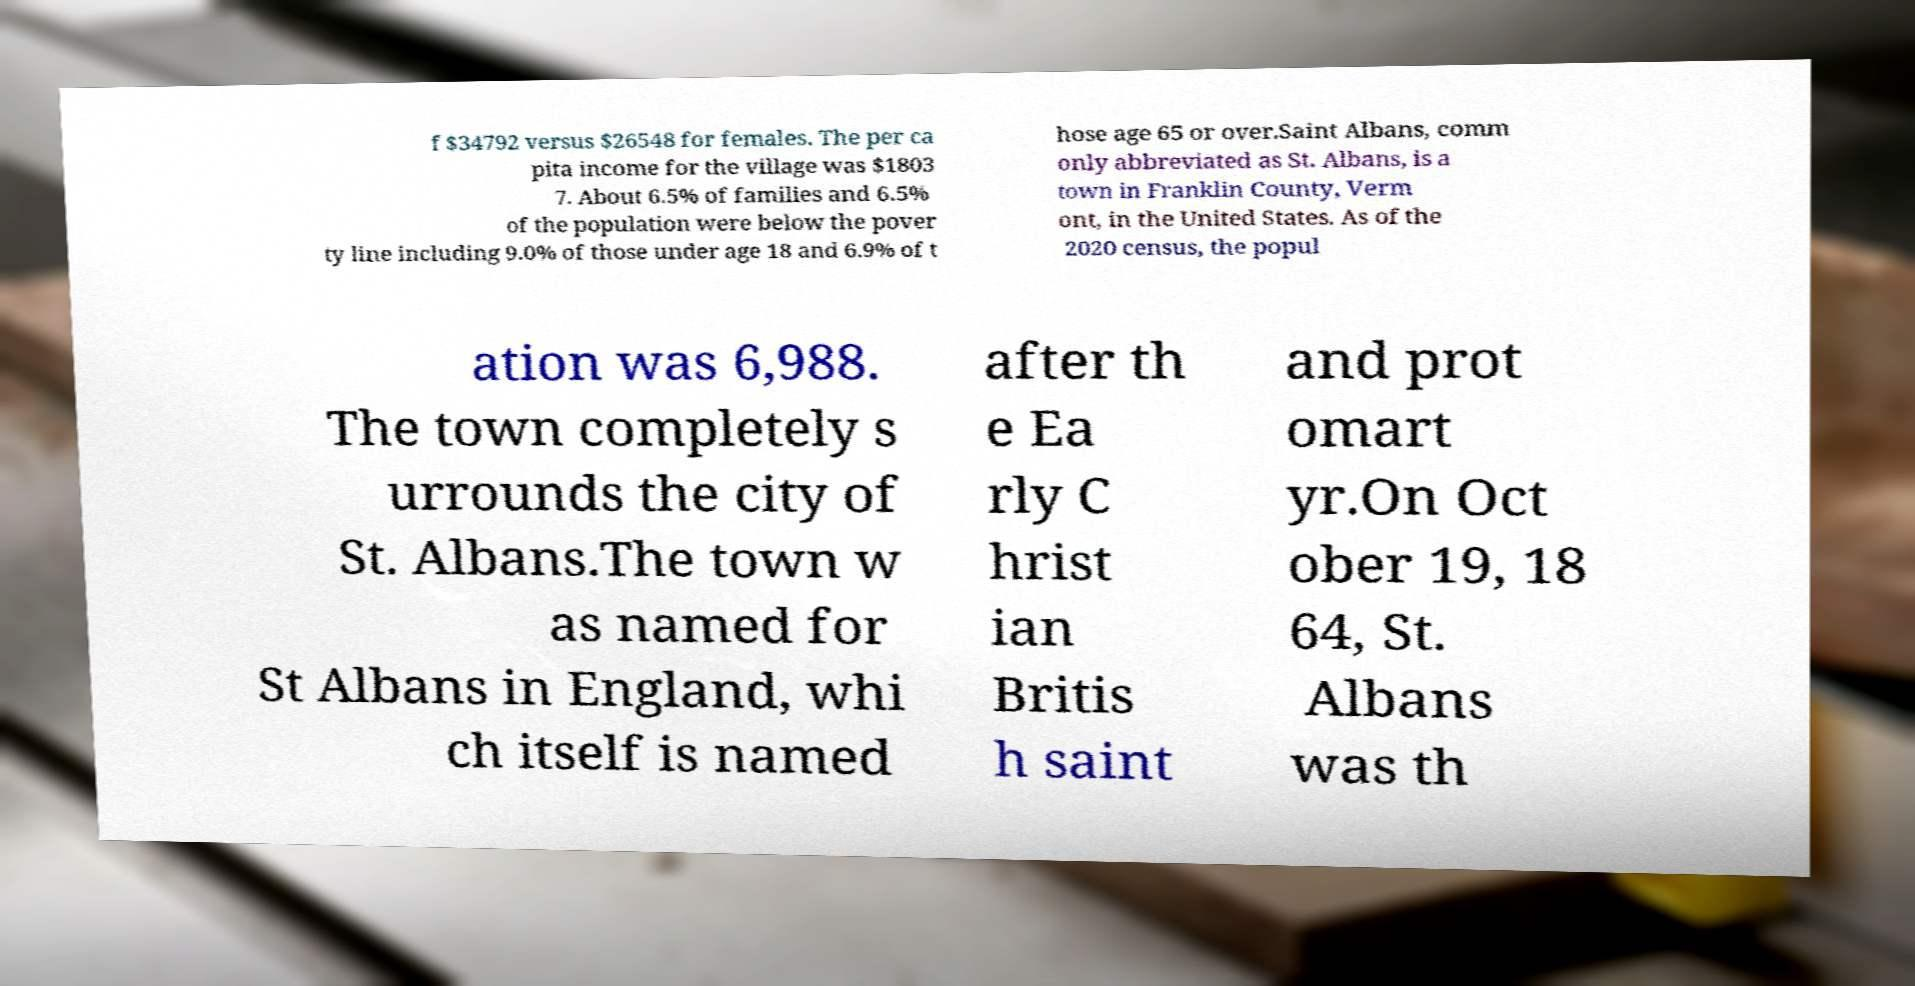Can you accurately transcribe the text from the provided image for me? f $34792 versus $26548 for females. The per ca pita income for the village was $1803 7. About 6.5% of families and 6.5% of the population were below the pover ty line including 9.0% of those under age 18 and 6.9% of t hose age 65 or over.Saint Albans, comm only abbreviated as St. Albans, is a town in Franklin County, Verm ont, in the United States. As of the 2020 census, the popul ation was 6,988. The town completely s urrounds the city of St. Albans.The town w as named for St Albans in England, whi ch itself is named after th e Ea rly C hrist ian Britis h saint and prot omart yr.On Oct ober 19, 18 64, St. Albans was th 